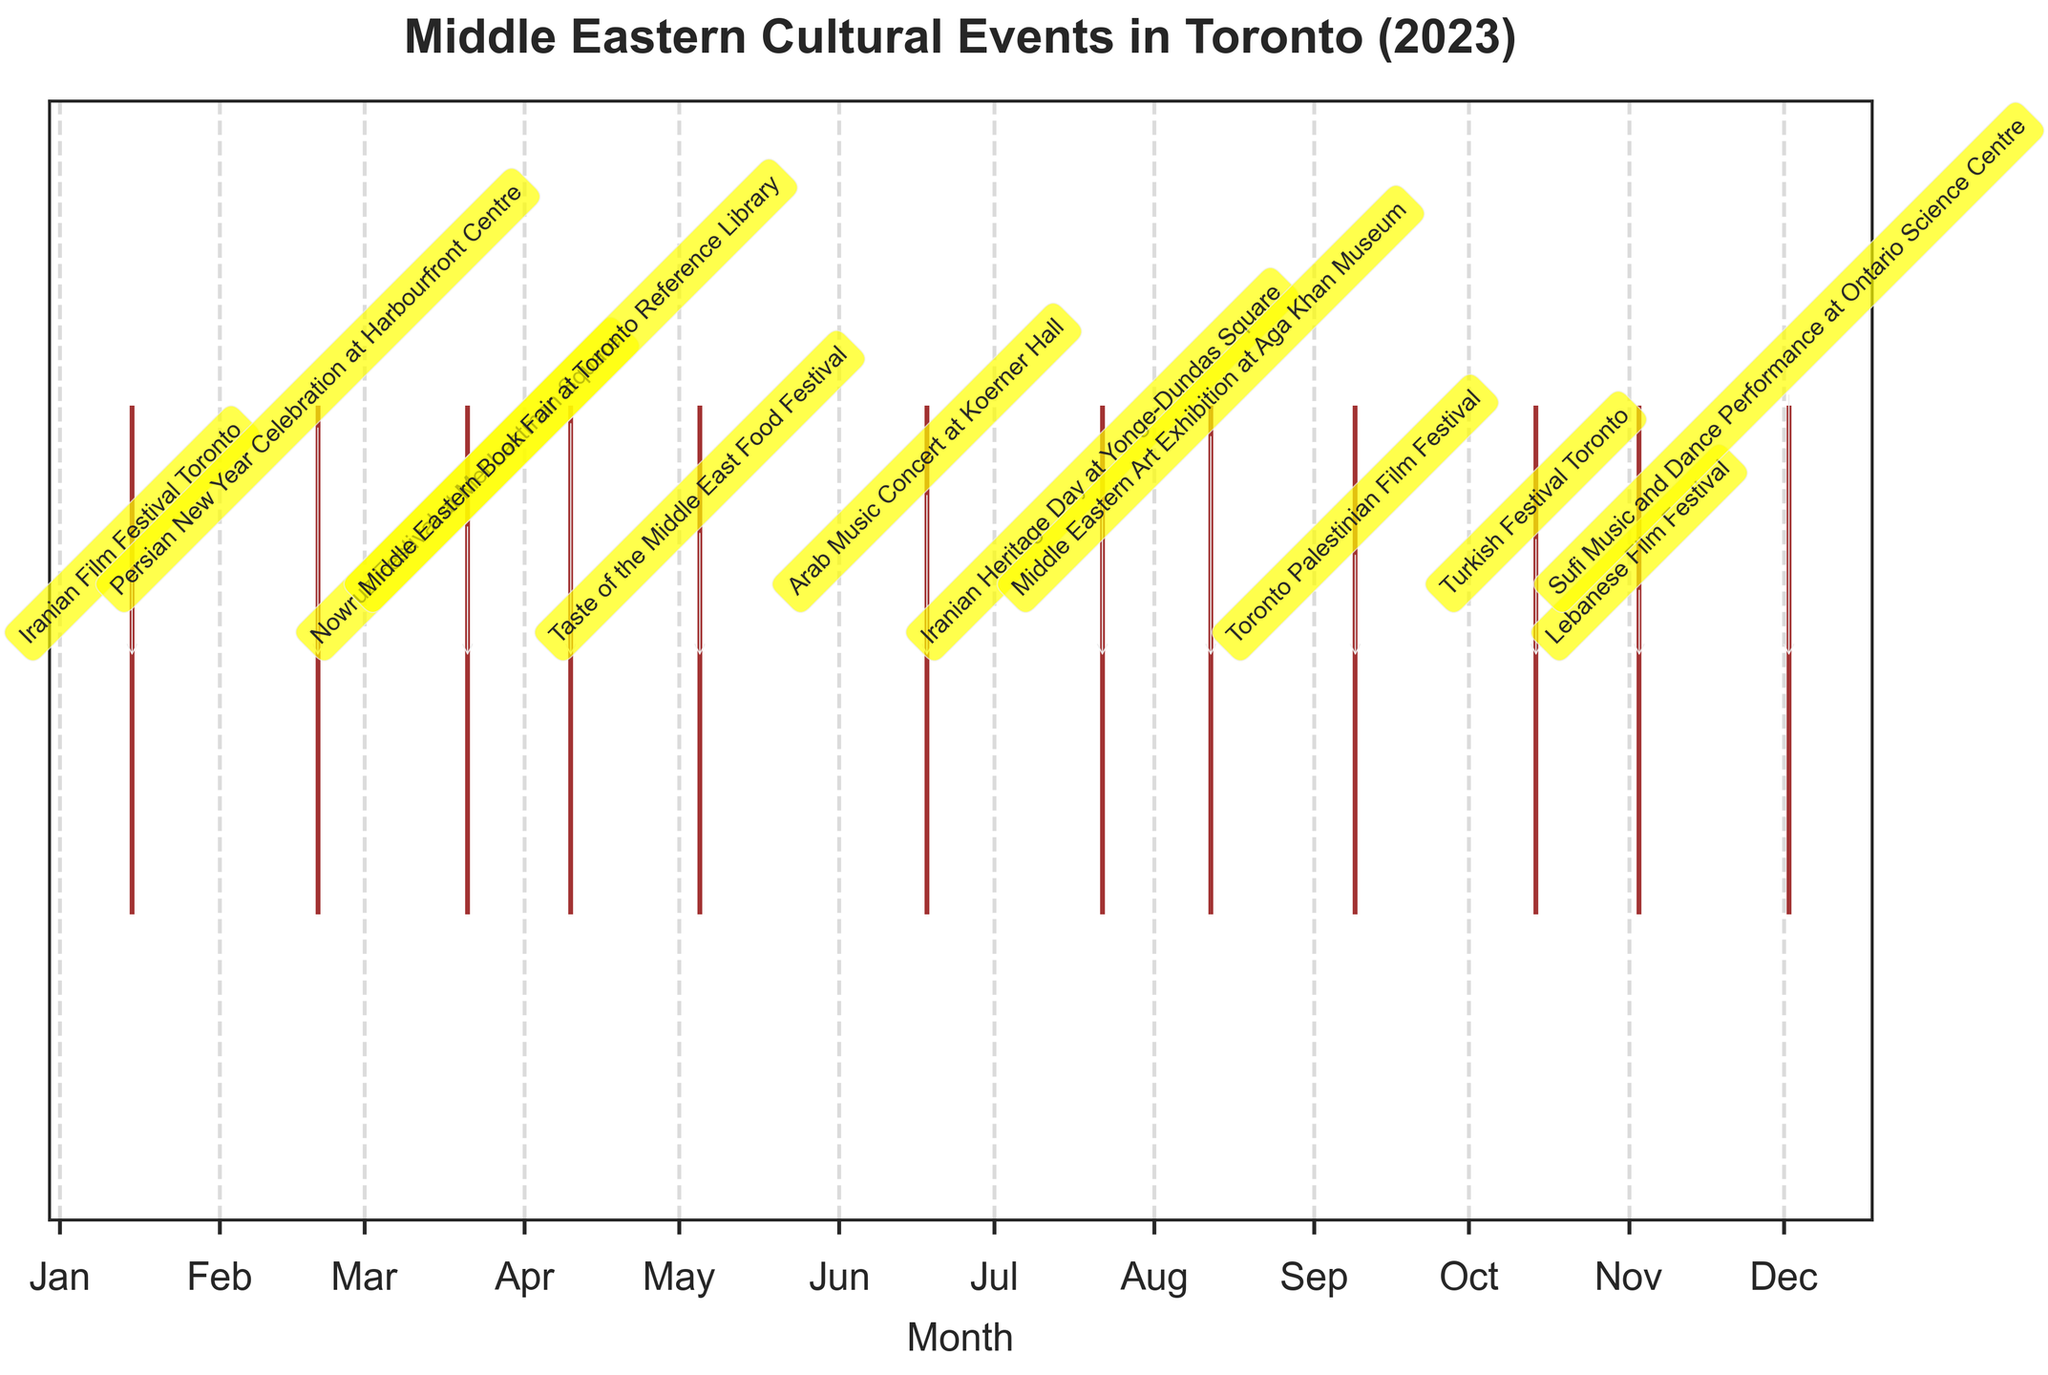What's the title of the plot? The title is displayed at the top of the figure in bold and larger font size. It reads "Middle Eastern Cultural Events in Toronto (2023)".
Answer: Middle Eastern Cultural Events in Toronto (2023) What is the label of the x-axis? The x-axis label is located below the x-axis and it reads "Month".
Answer: Month Which cultural event occurs in May? The event plot shows event names annotated next to each date. For May, it shows the "Taste of the Middle East Food Festival" event.
Answer: Taste of the Middle East Food Festival How many Middle Eastern cultural events are listed in the plot? By counting the number of event labels annotated in the plot, you can see that there are 12 events.
Answer: 12 How does the frequency of events change throughout the year? By observing the distribution of events along the x-axis, events occur fairly evenly throughout the year with no significant clustering in any particular month.
Answer: Events occur fairly evenly throughout the year Which month has the most number of events? By counting the events in each month, March has two events ("Nowruz Festival at Mel Lastman Square" and "Persian New Year Celebration at Harbourfront Centre"), which is the highest number of events in any month.
Answer: March Is there any month without a Middle Eastern cultural event? By checking each month on the x-axis, you can see that every month has at least one cultural event.
Answer: No What are the two consecutive months that both feature a film festival? By observing the event annotations, you can see that the "Toronto Palestinian Film Festival" occurs in September and the "Lebanese Film Festival" occurs in November. September and November are two consecutive months with film festivals.
Answer: September and October How many types of cultural events (e.g., film festivals, music, food) are represented in the plot? By categorizing the events based on their types, you find that there are four main types: film festivals, music, food festivals, and other cultural celebrations/exhibitions (e.g., book fair, art exhibition).
Answer: 4 types 